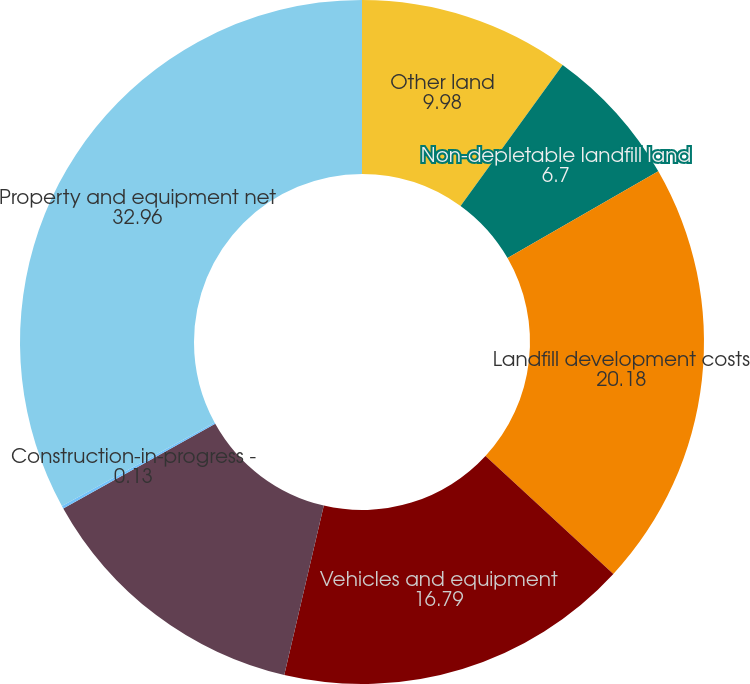<chart> <loc_0><loc_0><loc_500><loc_500><pie_chart><fcel>Other land<fcel>Non-depletable landfill land<fcel>Landfill development costs<fcel>Vehicles and equipment<fcel>Buildings and improvements<fcel>Construction-in-progress -<fcel>Property and equipment net<nl><fcel>9.98%<fcel>6.7%<fcel>20.18%<fcel>16.79%<fcel>13.26%<fcel>0.13%<fcel>32.96%<nl></chart> 